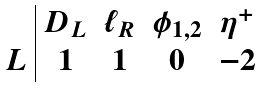Convert formula to latex. <formula><loc_0><loc_0><loc_500><loc_500>\begin{array} { c | c c c c } & D _ { L } & \ell _ { R } & \phi _ { 1 , 2 } & \eta ^ { + } \\ L & 1 & 1 & 0 & - 2 \end{array}</formula> 